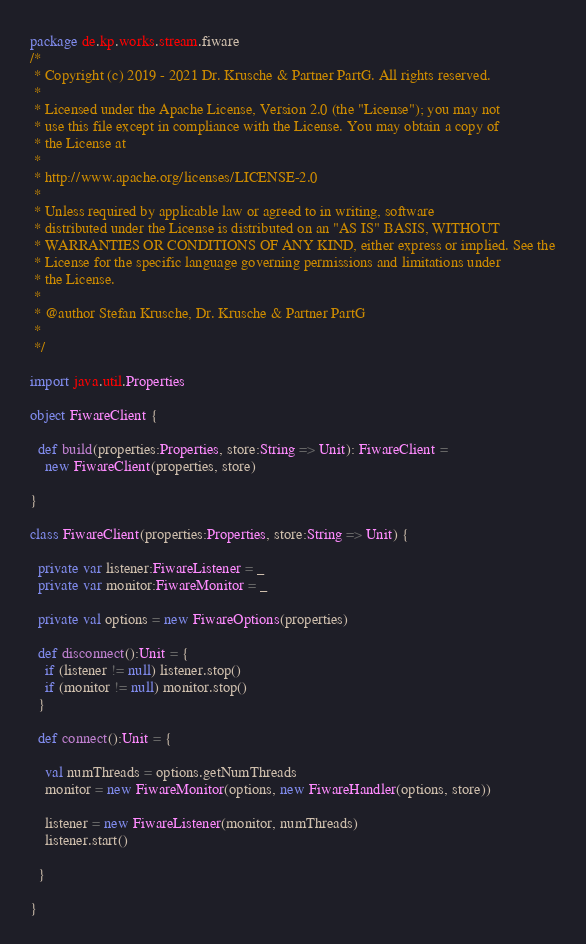<code> <loc_0><loc_0><loc_500><loc_500><_Scala_>package de.kp.works.stream.fiware
/*
 * Copyright (c) 2019 - 2021 Dr. Krusche & Partner PartG. All rights reserved.
 *
 * Licensed under the Apache License, Version 2.0 (the "License"); you may not
 * use this file except in compliance with the License. You may obtain a copy of
 * the License at
 *
 * http://www.apache.org/licenses/LICENSE-2.0
 *
 * Unless required by applicable law or agreed to in writing, software
 * distributed under the License is distributed on an "AS IS" BASIS, WITHOUT
 * WARRANTIES OR CONDITIONS OF ANY KIND, either express or implied. See the
 * License for the specific language governing permissions and limitations under
 * the License.
 *
 * @author Stefan Krusche, Dr. Krusche & Partner PartG
 *
 */

import java.util.Properties

object FiwareClient {

  def build(properties:Properties, store:String => Unit): FiwareClient =
    new FiwareClient(properties, store)

}

class FiwareClient(properties:Properties, store:String => Unit) {

  private var listener:FiwareListener = _
  private var monitor:FiwareMonitor = _

  private val options = new FiwareOptions(properties)

  def disconnect():Unit = {
    if (listener != null) listener.stop()
    if (monitor != null) monitor.stop()
  }

  def connect():Unit = {

    val numThreads = options.getNumThreads
    monitor = new FiwareMonitor(options, new FiwareHandler(options, store))

    listener = new FiwareListener(monitor, numThreads)
    listener.start()

  }

}
</code> 